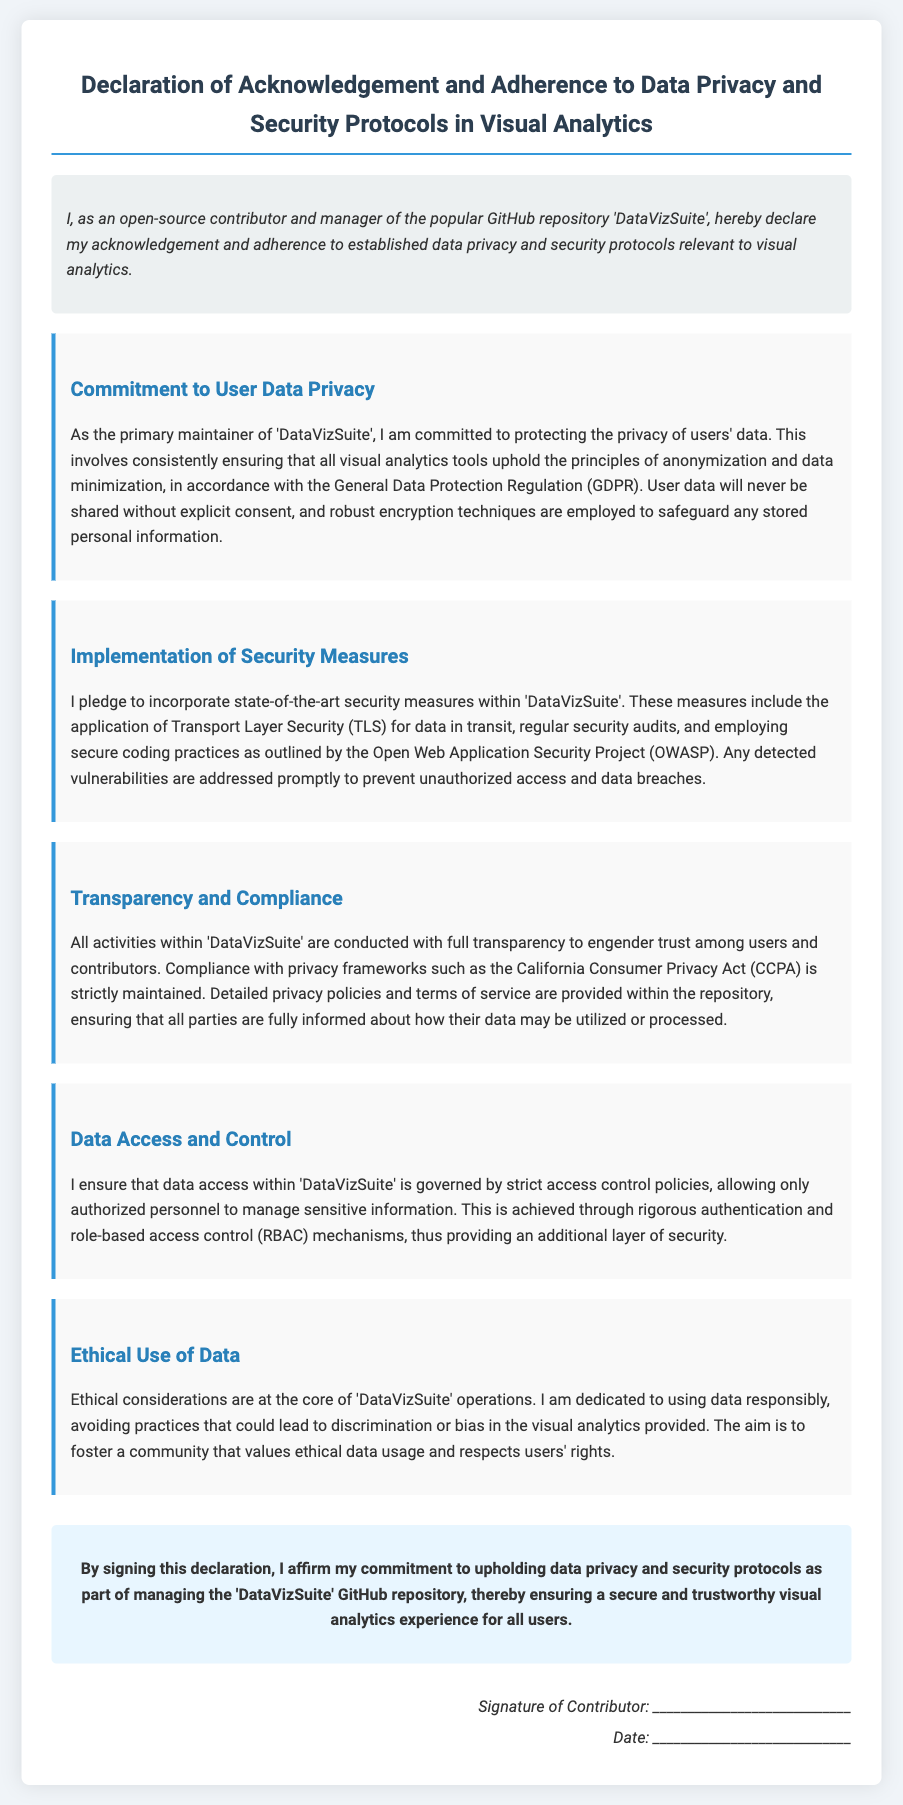What is the title of the document? The title of the document appears at the top and sets the theme for the declaration.
Answer: Declaration of Acknowledgement and Adherence to Data Privacy and Security Protocols in Visual Analytics Who is the primary maintainer of 'DataVizSuite'? The primary maintainer is mentioned at the beginning of the introduction, indicating ownership of the repository.
Answer: I What regulatory framework is referenced for user data protection? The document mentions a specific regulation that governs data privacy practices.
Answer: General Data Protection Regulation (GDPR) What security measures are specified for data in transit? The specific security technique used for protecting data during transmission is detailed in the implementation section.
Answer: Transport Layer Security (TLS) Which act does the document comply with apart from GDPR? An additional privacy framework mentioned in the document illustrates compliance to further regulations.
Answer: California Consumer Privacy Act (CCPA) What is emphasized as the core of 'DataVizSuite' operations? This phrase outlines the fundamental principle guiding the ethical considerations in handling data.
Answer: Ethical considerations What method is used for managing access to sensitive information? The document details the approach used to ensure that only authorized personnel access sensitive data.
Answer: Role-based access control (RBAC) What is included within the repository to inform users about data usage? This information is a component of maintaining transparency as stated in the document.
Answer: Detailed privacy policies and terms of service What does signing the declaration affirm? The conclusion explains what signing the document confirms regarding the contributor's commitment.
Answer: Commitment to upholding data privacy and security protocols 